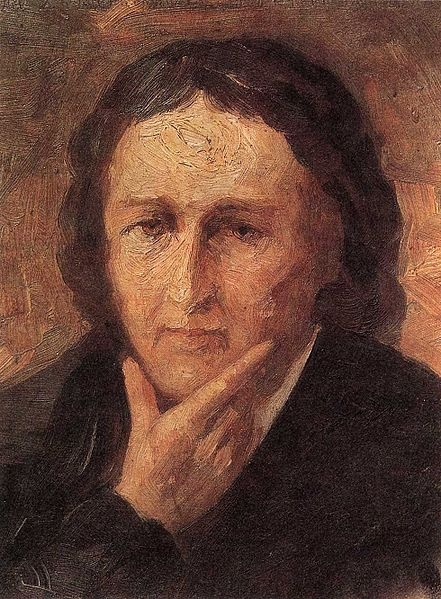Describe the art techniques used in this portrait. The artist has employed post-impressionistic techniques in this portrait. The background's vibrant blend of warm colors is created with broad, expressive brushstrokes, establishing a dramatic and emotion-laden setting. The detailed depiction of the individual's face contrasts with the abstract background, focusing the viewer's attention on the emotions conveyed through their expression. This strategic use of color and brushstroke enhances the overall emotional impact and depth of the artwork. 